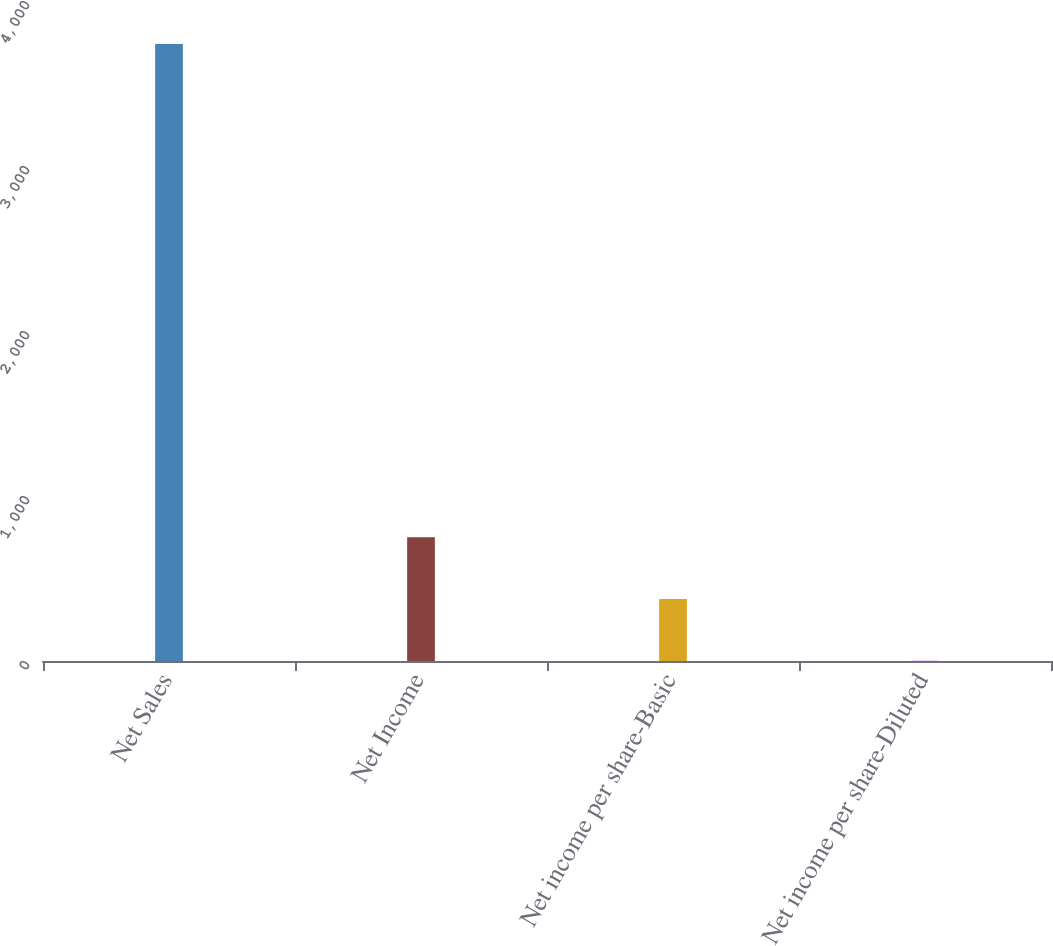Convert chart to OTSL. <chart><loc_0><loc_0><loc_500><loc_500><bar_chart><fcel>Net Sales<fcel>Net Income<fcel>Net income per share-Basic<fcel>Net income per share-Diluted<nl><fcel>3739.3<fcel>749.28<fcel>375.53<fcel>1.78<nl></chart> 